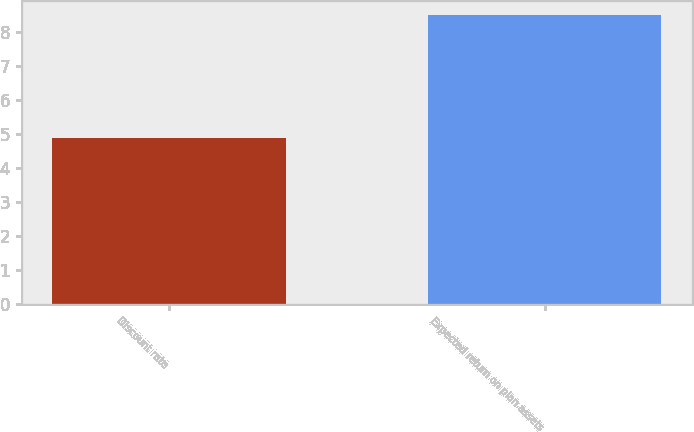Convert chart. <chart><loc_0><loc_0><loc_500><loc_500><bar_chart><fcel>Discount rate<fcel>Expected return on plan assets<nl><fcel>4.89<fcel>8.5<nl></chart> 